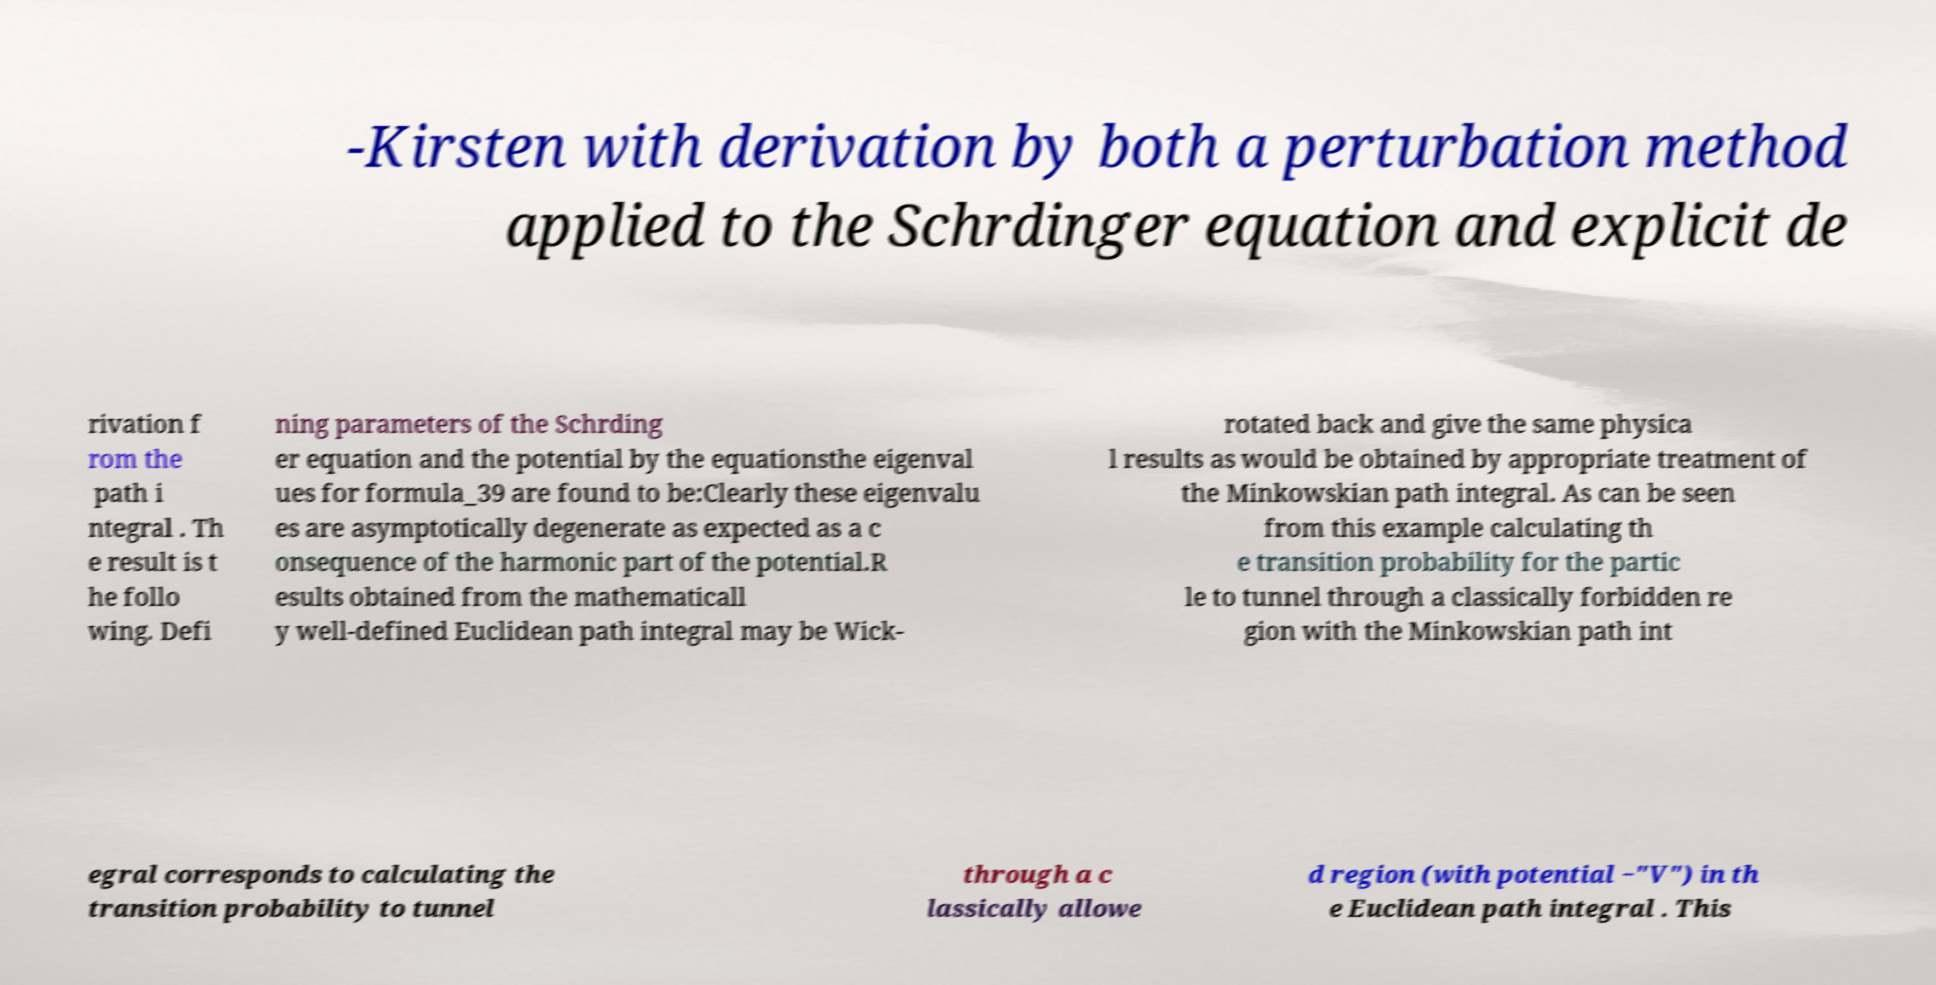What messages or text are displayed in this image? I need them in a readable, typed format. -Kirsten with derivation by both a perturbation method applied to the Schrdinger equation and explicit de rivation f rom the path i ntegral . Th e result is t he follo wing. Defi ning parameters of the Schrding er equation and the potential by the equationsthe eigenval ues for formula_39 are found to be:Clearly these eigenvalu es are asymptotically degenerate as expected as a c onsequence of the harmonic part of the potential.R esults obtained from the mathematicall y well-defined Euclidean path integral may be Wick- rotated back and give the same physica l results as would be obtained by appropriate treatment of the Minkowskian path integral. As can be seen from this example calculating th e transition probability for the partic le to tunnel through a classically forbidden re gion with the Minkowskian path int egral corresponds to calculating the transition probability to tunnel through a c lassically allowe d region (with potential −"V") in th e Euclidean path integral . This 